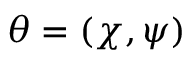Convert formula to latex. <formula><loc_0><loc_0><loc_500><loc_500>\theta = ( \chi , \psi )</formula> 